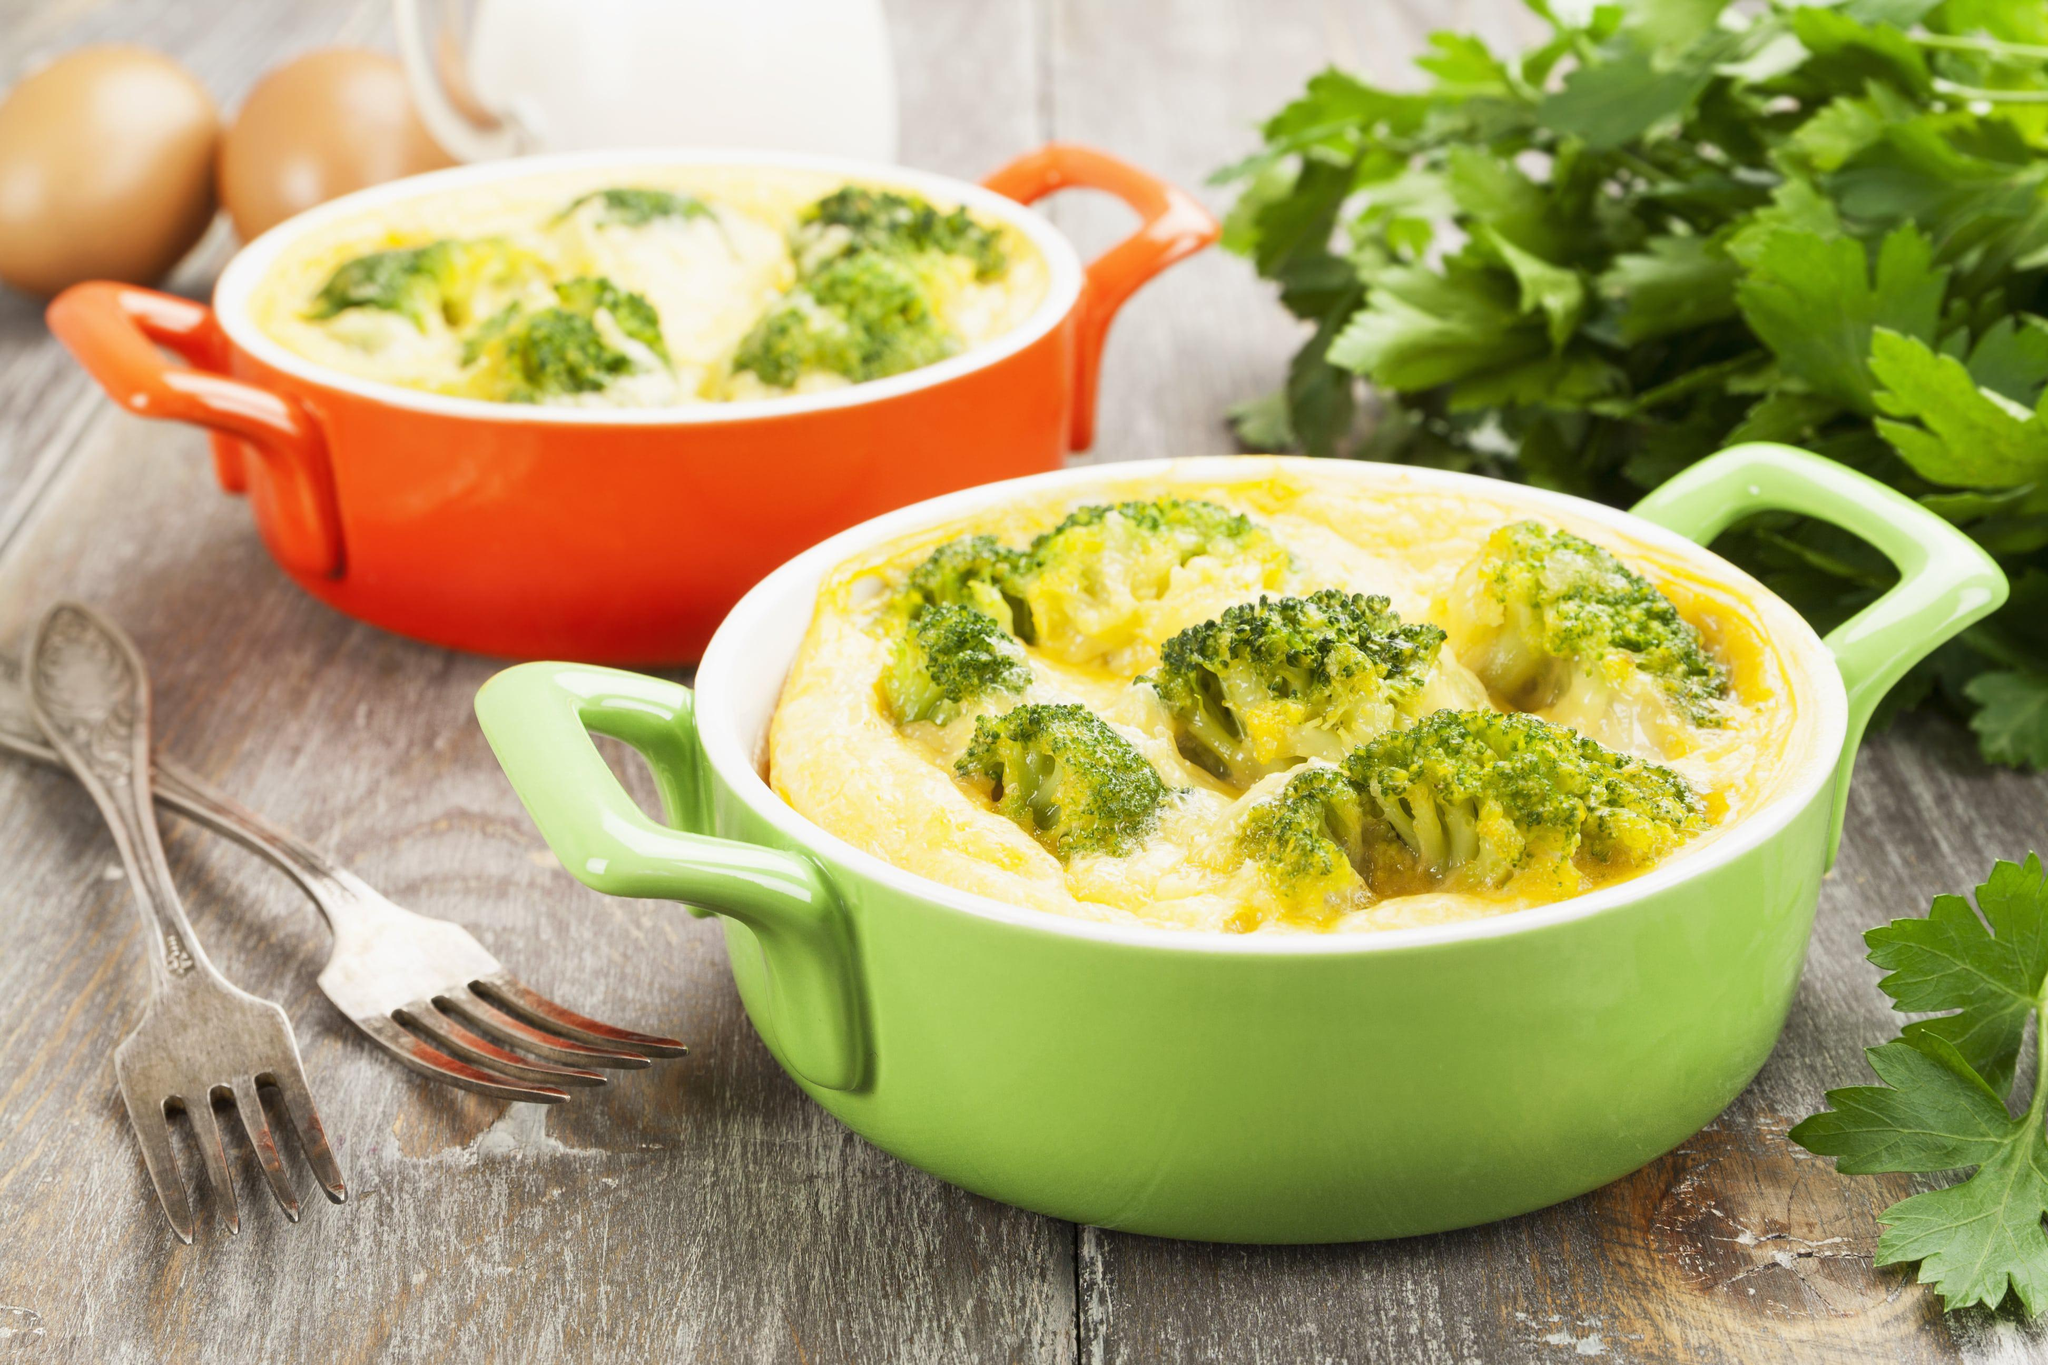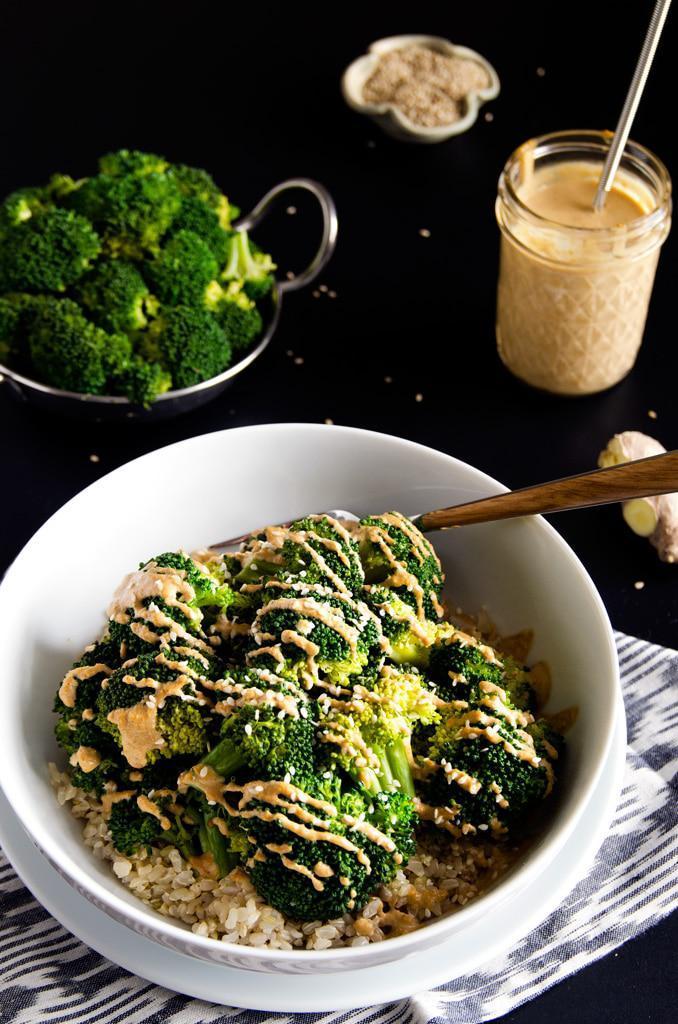The first image is the image on the left, the second image is the image on the right. Considering the images on both sides, is "There are two white bowls." valid? Answer yes or no. No. 